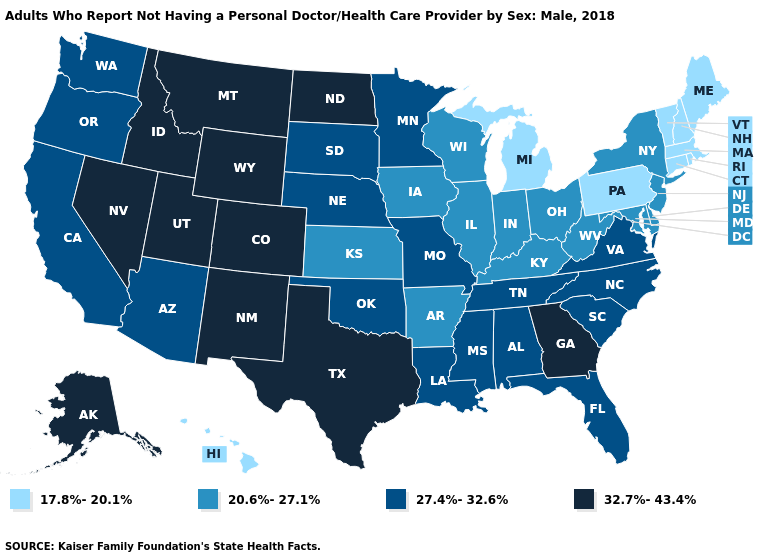Which states have the highest value in the USA?
Write a very short answer. Alaska, Colorado, Georgia, Idaho, Montana, Nevada, New Mexico, North Dakota, Texas, Utah, Wyoming. Which states have the highest value in the USA?
Write a very short answer. Alaska, Colorado, Georgia, Idaho, Montana, Nevada, New Mexico, North Dakota, Texas, Utah, Wyoming. Which states hav the highest value in the MidWest?
Write a very short answer. North Dakota. Which states have the highest value in the USA?
Write a very short answer. Alaska, Colorado, Georgia, Idaho, Montana, Nevada, New Mexico, North Dakota, Texas, Utah, Wyoming. What is the lowest value in the USA?
Give a very brief answer. 17.8%-20.1%. Does Utah have the highest value in the USA?
Concise answer only. Yes. What is the value of Missouri?
Give a very brief answer. 27.4%-32.6%. Does Pennsylvania have the lowest value in the USA?
Short answer required. Yes. Name the states that have a value in the range 32.7%-43.4%?
Answer briefly. Alaska, Colorado, Georgia, Idaho, Montana, Nevada, New Mexico, North Dakota, Texas, Utah, Wyoming. Name the states that have a value in the range 27.4%-32.6%?
Give a very brief answer. Alabama, Arizona, California, Florida, Louisiana, Minnesota, Mississippi, Missouri, Nebraska, North Carolina, Oklahoma, Oregon, South Carolina, South Dakota, Tennessee, Virginia, Washington. Name the states that have a value in the range 32.7%-43.4%?
Short answer required. Alaska, Colorado, Georgia, Idaho, Montana, Nevada, New Mexico, North Dakota, Texas, Utah, Wyoming. Name the states that have a value in the range 32.7%-43.4%?
Be succinct. Alaska, Colorado, Georgia, Idaho, Montana, Nevada, New Mexico, North Dakota, Texas, Utah, Wyoming. Which states have the highest value in the USA?
Answer briefly. Alaska, Colorado, Georgia, Idaho, Montana, Nevada, New Mexico, North Dakota, Texas, Utah, Wyoming. Does Kentucky have a higher value than Pennsylvania?
Keep it brief. Yes. Does Pennsylvania have a lower value than South Dakota?
Answer briefly. Yes. 